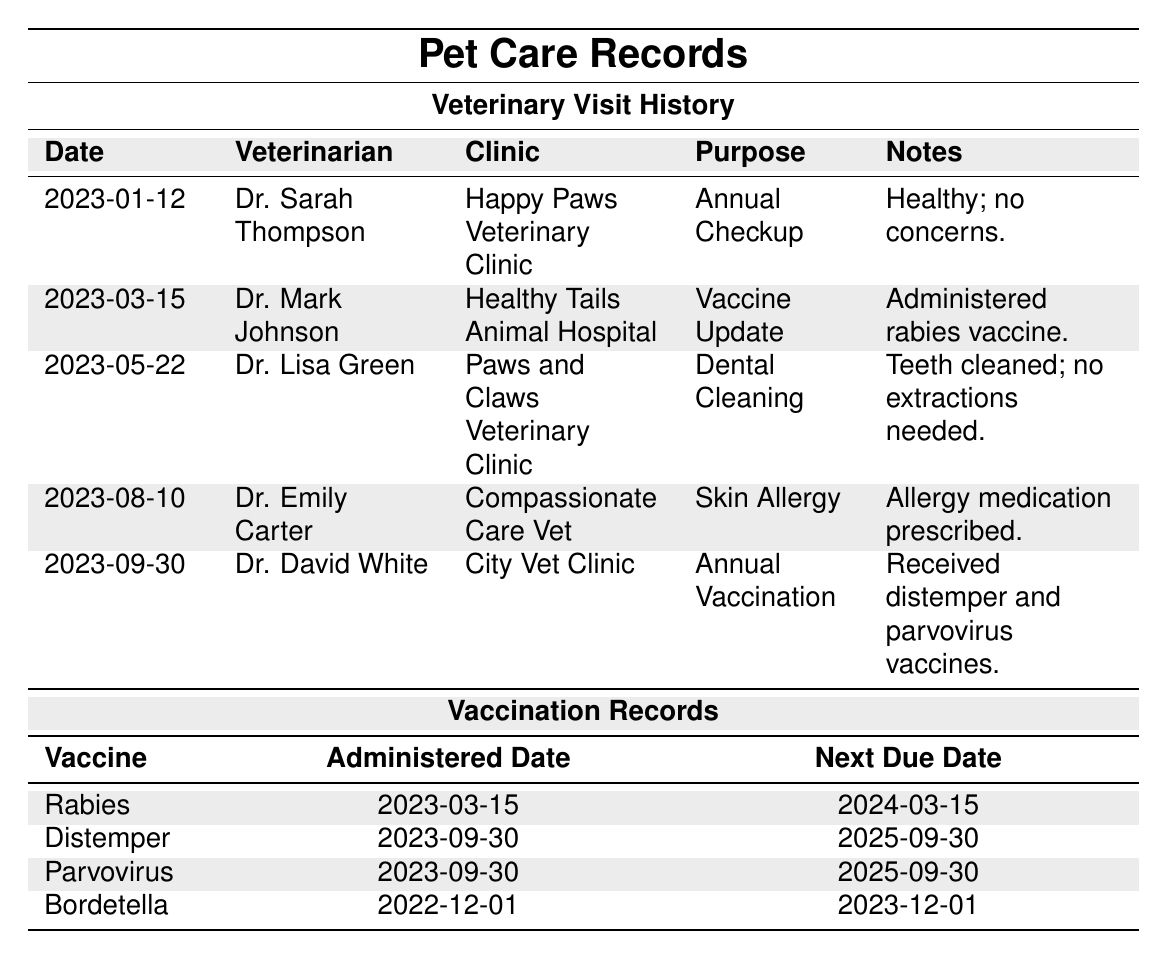What was the purpose of the Veterinary visit on March 15, 2023? The table shows a row for the visit on March 15, 2023, where the purpose is listed as "Vaccine Update."
Answer: Vaccine Update Who performed the dental cleaning in May 2023? According to the table, Dr. Lisa Green conducted the dental cleaning on May 22, 2023.
Answer: Dr. Lisa Green Is there a vaccination due before March 15, 2024? Looking at the vaccination records, the Bordetella vaccine is due on December 1, 2023, which is before March 15, 2024.
Answer: Yes How many vaccines were administered in the year 2023? The table lists two vaccination dates in 2023: March 15 (Rabies) and September 30 (Distemper and Parvovirus). Thus, three vaccines were administered in total.
Answer: 3 Which veterinarian had the most recent visit listed? The most recent visit in the table is on September 30, 2023, which was conducted by Dr. David White.
Answer: Dr. David White What vaccine was administered on September 30, 2023? The table shows that on September 30, 2023, both the Distemper and Parvovirus vaccines were administered.
Answer: Distemper and Parvovirus When is the next due date for the Bordetella vaccine? The next due date for the Bordetella vaccine is recorded as December 1, 2023, in the vaccination records section of the table.
Answer: December 1, 2023 How many different clinics were visited for the veterinary checks in 2023? In the table, there are five veterinary visits listed in 2023, each taking place at a different clinic: Happy Paws Veterinary Clinic, Healthy Tails Animal Hospital, Paws and Claws Veterinary Clinic, Compassionate Care Vet, and City Vet Clinic, resulting in five unique clinics.
Answer: 5 What is the time span between the first and last veterinary visit recorded? The first visit is dated January 12, 2023, and the last visit is on September 30, 2023. The time span calculated is about 9 months and 18 days.
Answer: About 9 months and 18 days Did any visit involve an annual checkup? Yes, the visit on January 12, 2023, is marked as an annual checkup in the table.
Answer: Yes 